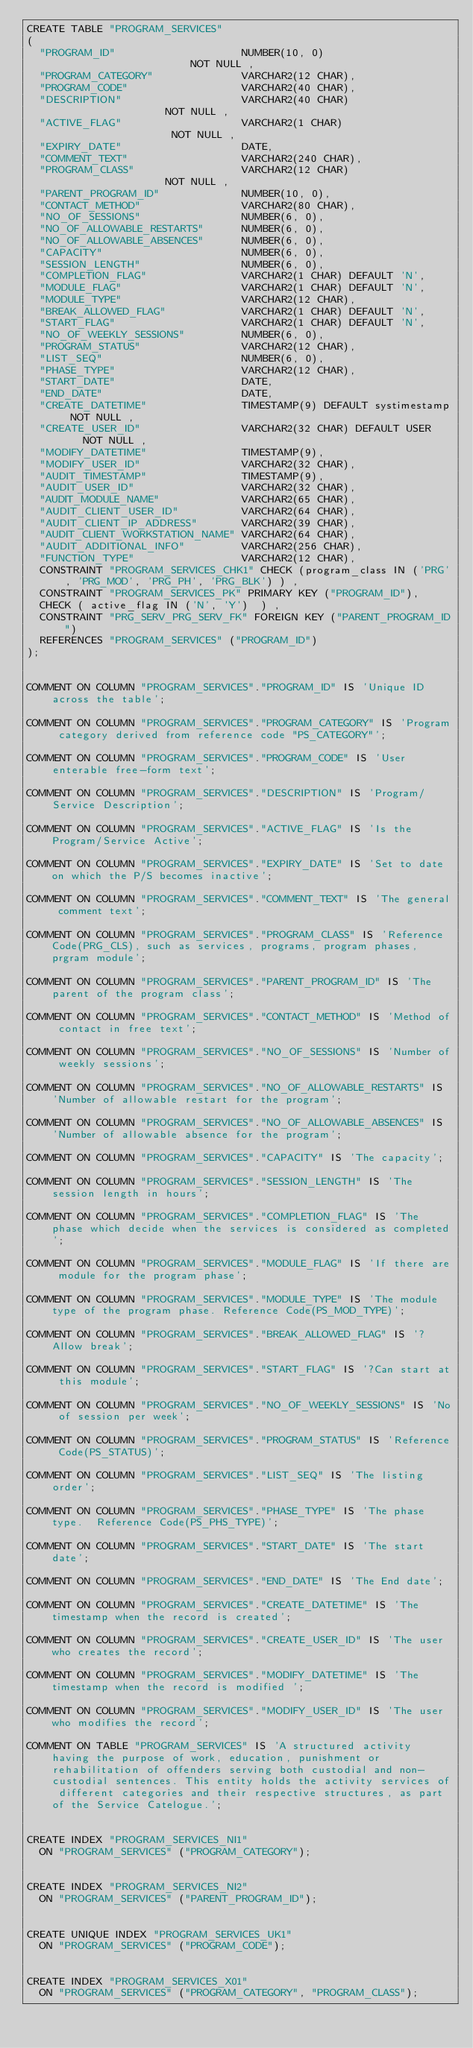<code> <loc_0><loc_0><loc_500><loc_500><_SQL_>CREATE TABLE "PROGRAM_SERVICES"
(
  "PROGRAM_ID"                    NUMBER(10, 0)                     NOT NULL ,
  "PROGRAM_CATEGORY"              VARCHAR2(12 CHAR),
  "PROGRAM_CODE"                  VARCHAR2(40 CHAR),
  "DESCRIPTION"                   VARCHAR2(40 CHAR)                 NOT NULL ,
  "ACTIVE_FLAG"                   VARCHAR2(1 CHAR)                  NOT NULL ,
  "EXPIRY_DATE"                   DATE,
  "COMMENT_TEXT"                  VARCHAR2(240 CHAR),
  "PROGRAM_CLASS"                 VARCHAR2(12 CHAR)                 NOT NULL ,
  "PARENT_PROGRAM_ID"             NUMBER(10, 0),
  "CONTACT_METHOD"                VARCHAR2(80 CHAR),
  "NO_OF_SESSIONS"                NUMBER(6, 0),
  "NO_OF_ALLOWABLE_RESTARTS"      NUMBER(6, 0),
  "NO_OF_ALLOWABLE_ABSENCES"      NUMBER(6, 0),
  "CAPACITY"                      NUMBER(6, 0),
  "SESSION_LENGTH"                NUMBER(6, 0),
  "COMPLETION_FLAG"               VARCHAR2(1 CHAR) DEFAULT 'N',
  "MODULE_FLAG"                   VARCHAR2(1 CHAR) DEFAULT 'N',
  "MODULE_TYPE"                   VARCHAR2(12 CHAR),
  "BREAK_ALLOWED_FLAG"            VARCHAR2(1 CHAR) DEFAULT 'N',
  "START_FLAG"                    VARCHAR2(1 CHAR) DEFAULT 'N',
  "NO_OF_WEEKLY_SESSIONS"         NUMBER(6, 0),
  "PROGRAM_STATUS"                VARCHAR2(12 CHAR),
  "LIST_SEQ"                      NUMBER(6, 0),
  "PHASE_TYPE"                    VARCHAR2(12 CHAR),
  "START_DATE"                    DATE,
  "END_DATE"                      DATE,
  "CREATE_DATETIME"               TIMESTAMP(9) DEFAULT systimestamp NOT NULL ,
  "CREATE_USER_ID"                VARCHAR2(32 CHAR) DEFAULT USER    NOT NULL ,
  "MODIFY_DATETIME"               TIMESTAMP(9),
  "MODIFY_USER_ID"                VARCHAR2(32 CHAR),
  "AUDIT_TIMESTAMP"               TIMESTAMP(9),
  "AUDIT_USER_ID"                 VARCHAR2(32 CHAR),
  "AUDIT_MODULE_NAME"             VARCHAR2(65 CHAR),
  "AUDIT_CLIENT_USER_ID"          VARCHAR2(64 CHAR),
  "AUDIT_CLIENT_IP_ADDRESS"       VARCHAR2(39 CHAR),
  "AUDIT_CLIENT_WORKSTATION_NAME" VARCHAR2(64 CHAR),
  "AUDIT_ADDITIONAL_INFO"         VARCHAR2(256 CHAR),
  "FUNCTION_TYPE"                 VARCHAR2(12 CHAR),
  CONSTRAINT "PROGRAM_SERVICES_CHK1" CHECK (program_class IN ('PRG', 'PRG_MOD', 'PRG_PH', 'PRG_BLK') ) ,
  CONSTRAINT "PROGRAM_SERVICES_PK" PRIMARY KEY ("PROGRAM_ID"),
  CHECK ( active_flag IN ('N', 'Y')  ) ,
  CONSTRAINT "PRG_SERV_PRG_SERV_FK" FOREIGN KEY ("PARENT_PROGRAM_ID")
  REFERENCES "PROGRAM_SERVICES" ("PROGRAM_ID")
);


COMMENT ON COLUMN "PROGRAM_SERVICES"."PROGRAM_ID" IS 'Unique ID across the table';

COMMENT ON COLUMN "PROGRAM_SERVICES"."PROGRAM_CATEGORY" IS 'Program category derived from reference code "PS_CATEGORY"';

COMMENT ON COLUMN "PROGRAM_SERVICES"."PROGRAM_CODE" IS 'User enterable free-form text';

COMMENT ON COLUMN "PROGRAM_SERVICES"."DESCRIPTION" IS 'Program/Service Description';

COMMENT ON COLUMN "PROGRAM_SERVICES"."ACTIVE_FLAG" IS 'Is the Program/Service Active';

COMMENT ON COLUMN "PROGRAM_SERVICES"."EXPIRY_DATE" IS 'Set to date on which the P/S becomes inactive';

COMMENT ON COLUMN "PROGRAM_SERVICES"."COMMENT_TEXT" IS 'The general comment text';

COMMENT ON COLUMN "PROGRAM_SERVICES"."PROGRAM_CLASS" IS 'Reference Code(PRG_CLS), such as services, programs, program phases, prgram module';

COMMENT ON COLUMN "PROGRAM_SERVICES"."PARENT_PROGRAM_ID" IS 'The parent of the program class';

COMMENT ON COLUMN "PROGRAM_SERVICES"."CONTACT_METHOD" IS 'Method of contact in free text';

COMMENT ON COLUMN "PROGRAM_SERVICES"."NO_OF_SESSIONS" IS 'Number of weekly sessions';

COMMENT ON COLUMN "PROGRAM_SERVICES"."NO_OF_ALLOWABLE_RESTARTS" IS 'Number of allowable restart for the program';

COMMENT ON COLUMN "PROGRAM_SERVICES"."NO_OF_ALLOWABLE_ABSENCES" IS 'Number of allowable absence for the program';

COMMENT ON COLUMN "PROGRAM_SERVICES"."CAPACITY" IS 'The capacity';

COMMENT ON COLUMN "PROGRAM_SERVICES"."SESSION_LENGTH" IS 'The session length in hours';

COMMENT ON COLUMN "PROGRAM_SERVICES"."COMPLETION_FLAG" IS 'The phase which decide when the services is considered as completed';

COMMENT ON COLUMN "PROGRAM_SERVICES"."MODULE_FLAG" IS 'If there are module for the program phase';

COMMENT ON COLUMN "PROGRAM_SERVICES"."MODULE_TYPE" IS 'The module type of the program phase. Reference Code(PS_MOD_TYPE)';

COMMENT ON COLUMN "PROGRAM_SERVICES"."BREAK_ALLOWED_FLAG" IS '?Allow break';

COMMENT ON COLUMN "PROGRAM_SERVICES"."START_FLAG" IS '?Can start at this module';

COMMENT ON COLUMN "PROGRAM_SERVICES"."NO_OF_WEEKLY_SESSIONS" IS 'No of session per week';

COMMENT ON COLUMN "PROGRAM_SERVICES"."PROGRAM_STATUS" IS 'Reference Code(PS_STATUS)';

COMMENT ON COLUMN "PROGRAM_SERVICES"."LIST_SEQ" IS 'The listing order';

COMMENT ON COLUMN "PROGRAM_SERVICES"."PHASE_TYPE" IS 'The phase type.  Reference Code(PS_PHS_TYPE)';

COMMENT ON COLUMN "PROGRAM_SERVICES"."START_DATE" IS 'The start date';

COMMENT ON COLUMN "PROGRAM_SERVICES"."END_DATE" IS 'The End date';

COMMENT ON COLUMN "PROGRAM_SERVICES"."CREATE_DATETIME" IS 'The timestamp when the record is created';

COMMENT ON COLUMN "PROGRAM_SERVICES"."CREATE_USER_ID" IS 'The user who creates the record';

COMMENT ON COLUMN "PROGRAM_SERVICES"."MODIFY_DATETIME" IS 'The timestamp when the record is modified ';

COMMENT ON COLUMN "PROGRAM_SERVICES"."MODIFY_USER_ID" IS 'The user who modifies the record';

COMMENT ON TABLE "PROGRAM_SERVICES" IS 'A structured activity having the purpose of work, education, punishment or rehabilitation of offenders serving both custodial and non-custodial sentences. This entity holds the activity services of different categories and their respective structures, as part of the Service Catelogue.';


CREATE INDEX "PROGRAM_SERVICES_NI1"
  ON "PROGRAM_SERVICES" ("PROGRAM_CATEGORY");


CREATE INDEX "PROGRAM_SERVICES_NI2"
  ON "PROGRAM_SERVICES" ("PARENT_PROGRAM_ID");


CREATE UNIQUE INDEX "PROGRAM_SERVICES_UK1"
  ON "PROGRAM_SERVICES" ("PROGRAM_CODE");


CREATE INDEX "PROGRAM_SERVICES_X01"
  ON "PROGRAM_SERVICES" ("PROGRAM_CATEGORY", "PROGRAM_CLASS");


</code> 